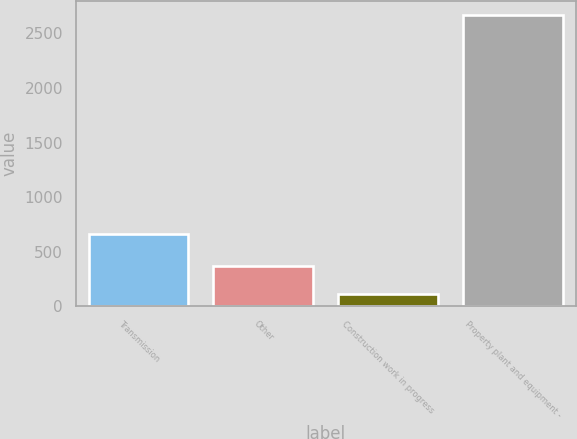Convert chart to OTSL. <chart><loc_0><loc_0><loc_500><loc_500><bar_chart><fcel>Transmission<fcel>Other<fcel>Construction work in progress<fcel>Property plant and equipment -<nl><fcel>658<fcel>369.2<fcel>114<fcel>2666<nl></chart> 